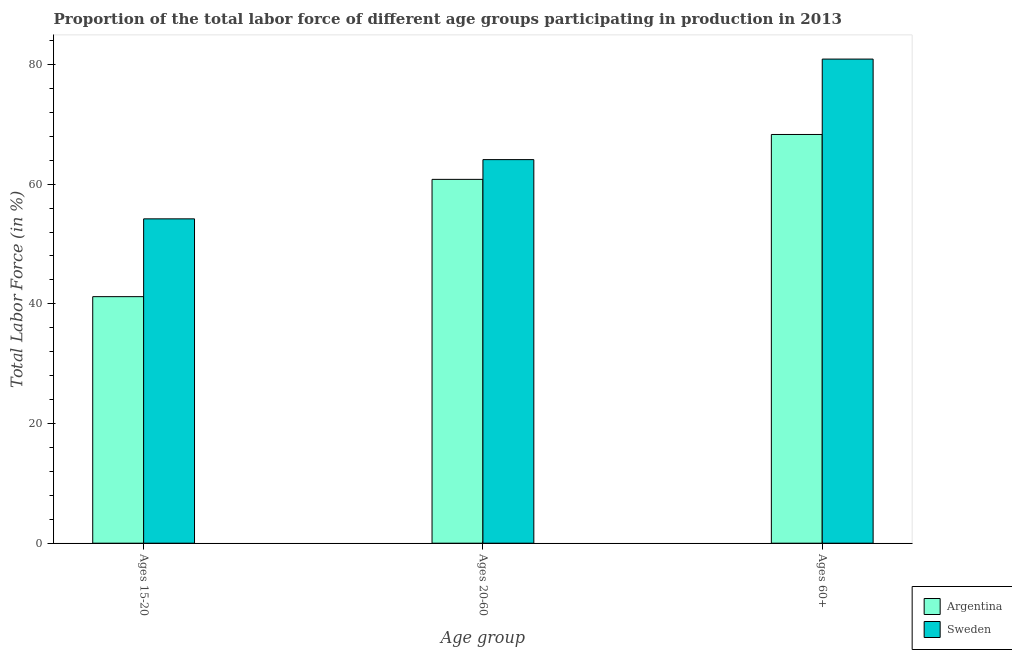How many different coloured bars are there?
Keep it short and to the point. 2. How many bars are there on the 1st tick from the left?
Provide a short and direct response. 2. What is the label of the 2nd group of bars from the left?
Your answer should be very brief. Ages 20-60. What is the percentage of labor force within the age group 15-20 in Argentina?
Offer a very short reply. 41.2. Across all countries, what is the maximum percentage of labor force within the age group 20-60?
Provide a succinct answer. 64.1. Across all countries, what is the minimum percentage of labor force within the age group 15-20?
Give a very brief answer. 41.2. In which country was the percentage of labor force within the age group 15-20 maximum?
Make the answer very short. Sweden. What is the total percentage of labor force above age 60 in the graph?
Your answer should be very brief. 149.2. What is the difference between the percentage of labor force within the age group 20-60 in Argentina and that in Sweden?
Make the answer very short. -3.3. What is the difference between the percentage of labor force within the age group 20-60 in Sweden and the percentage of labor force above age 60 in Argentina?
Provide a succinct answer. -4.2. What is the average percentage of labor force within the age group 20-60 per country?
Offer a very short reply. 62.45. What is the difference between the percentage of labor force above age 60 and percentage of labor force within the age group 15-20 in Argentina?
Give a very brief answer. 27.1. What is the ratio of the percentage of labor force above age 60 in Sweden to that in Argentina?
Offer a very short reply. 1.18. What is the difference between the highest and the second highest percentage of labor force within the age group 20-60?
Provide a short and direct response. 3.3. What is the difference between the highest and the lowest percentage of labor force within the age group 15-20?
Your response must be concise. 13. Is the sum of the percentage of labor force within the age group 20-60 in Sweden and Argentina greater than the maximum percentage of labor force within the age group 15-20 across all countries?
Provide a short and direct response. Yes. What does the 1st bar from the left in Ages 15-20 represents?
Give a very brief answer. Argentina. Is it the case that in every country, the sum of the percentage of labor force within the age group 15-20 and percentage of labor force within the age group 20-60 is greater than the percentage of labor force above age 60?
Your answer should be compact. Yes. Are all the bars in the graph horizontal?
Offer a very short reply. No. Does the graph contain any zero values?
Your answer should be very brief. No. How many legend labels are there?
Your response must be concise. 2. What is the title of the graph?
Provide a succinct answer. Proportion of the total labor force of different age groups participating in production in 2013. What is the label or title of the X-axis?
Give a very brief answer. Age group. What is the label or title of the Y-axis?
Give a very brief answer. Total Labor Force (in %). What is the Total Labor Force (in %) in Argentina in Ages 15-20?
Ensure brevity in your answer.  41.2. What is the Total Labor Force (in %) of Sweden in Ages 15-20?
Give a very brief answer. 54.2. What is the Total Labor Force (in %) in Argentina in Ages 20-60?
Make the answer very short. 60.8. What is the Total Labor Force (in %) of Sweden in Ages 20-60?
Offer a terse response. 64.1. What is the Total Labor Force (in %) of Argentina in Ages 60+?
Provide a short and direct response. 68.3. What is the Total Labor Force (in %) in Sweden in Ages 60+?
Give a very brief answer. 80.9. Across all Age group, what is the maximum Total Labor Force (in %) in Argentina?
Provide a short and direct response. 68.3. Across all Age group, what is the maximum Total Labor Force (in %) in Sweden?
Ensure brevity in your answer.  80.9. Across all Age group, what is the minimum Total Labor Force (in %) in Argentina?
Ensure brevity in your answer.  41.2. Across all Age group, what is the minimum Total Labor Force (in %) in Sweden?
Offer a very short reply. 54.2. What is the total Total Labor Force (in %) in Argentina in the graph?
Provide a succinct answer. 170.3. What is the total Total Labor Force (in %) in Sweden in the graph?
Provide a succinct answer. 199.2. What is the difference between the Total Labor Force (in %) in Argentina in Ages 15-20 and that in Ages 20-60?
Your answer should be compact. -19.6. What is the difference between the Total Labor Force (in %) in Sweden in Ages 15-20 and that in Ages 20-60?
Your answer should be very brief. -9.9. What is the difference between the Total Labor Force (in %) of Argentina in Ages 15-20 and that in Ages 60+?
Provide a succinct answer. -27.1. What is the difference between the Total Labor Force (in %) in Sweden in Ages 15-20 and that in Ages 60+?
Provide a succinct answer. -26.7. What is the difference between the Total Labor Force (in %) of Sweden in Ages 20-60 and that in Ages 60+?
Your response must be concise. -16.8. What is the difference between the Total Labor Force (in %) of Argentina in Ages 15-20 and the Total Labor Force (in %) of Sweden in Ages 20-60?
Provide a short and direct response. -22.9. What is the difference between the Total Labor Force (in %) of Argentina in Ages 15-20 and the Total Labor Force (in %) of Sweden in Ages 60+?
Keep it short and to the point. -39.7. What is the difference between the Total Labor Force (in %) in Argentina in Ages 20-60 and the Total Labor Force (in %) in Sweden in Ages 60+?
Your response must be concise. -20.1. What is the average Total Labor Force (in %) of Argentina per Age group?
Offer a terse response. 56.77. What is the average Total Labor Force (in %) of Sweden per Age group?
Offer a very short reply. 66.4. What is the difference between the Total Labor Force (in %) of Argentina and Total Labor Force (in %) of Sweden in Ages 15-20?
Offer a very short reply. -13. What is the ratio of the Total Labor Force (in %) in Argentina in Ages 15-20 to that in Ages 20-60?
Give a very brief answer. 0.68. What is the ratio of the Total Labor Force (in %) of Sweden in Ages 15-20 to that in Ages 20-60?
Your answer should be very brief. 0.85. What is the ratio of the Total Labor Force (in %) in Argentina in Ages 15-20 to that in Ages 60+?
Ensure brevity in your answer.  0.6. What is the ratio of the Total Labor Force (in %) in Sweden in Ages 15-20 to that in Ages 60+?
Offer a very short reply. 0.67. What is the ratio of the Total Labor Force (in %) in Argentina in Ages 20-60 to that in Ages 60+?
Offer a terse response. 0.89. What is the ratio of the Total Labor Force (in %) in Sweden in Ages 20-60 to that in Ages 60+?
Make the answer very short. 0.79. What is the difference between the highest and the second highest Total Labor Force (in %) in Argentina?
Your answer should be compact. 7.5. What is the difference between the highest and the second highest Total Labor Force (in %) in Sweden?
Your response must be concise. 16.8. What is the difference between the highest and the lowest Total Labor Force (in %) of Argentina?
Keep it short and to the point. 27.1. What is the difference between the highest and the lowest Total Labor Force (in %) of Sweden?
Give a very brief answer. 26.7. 